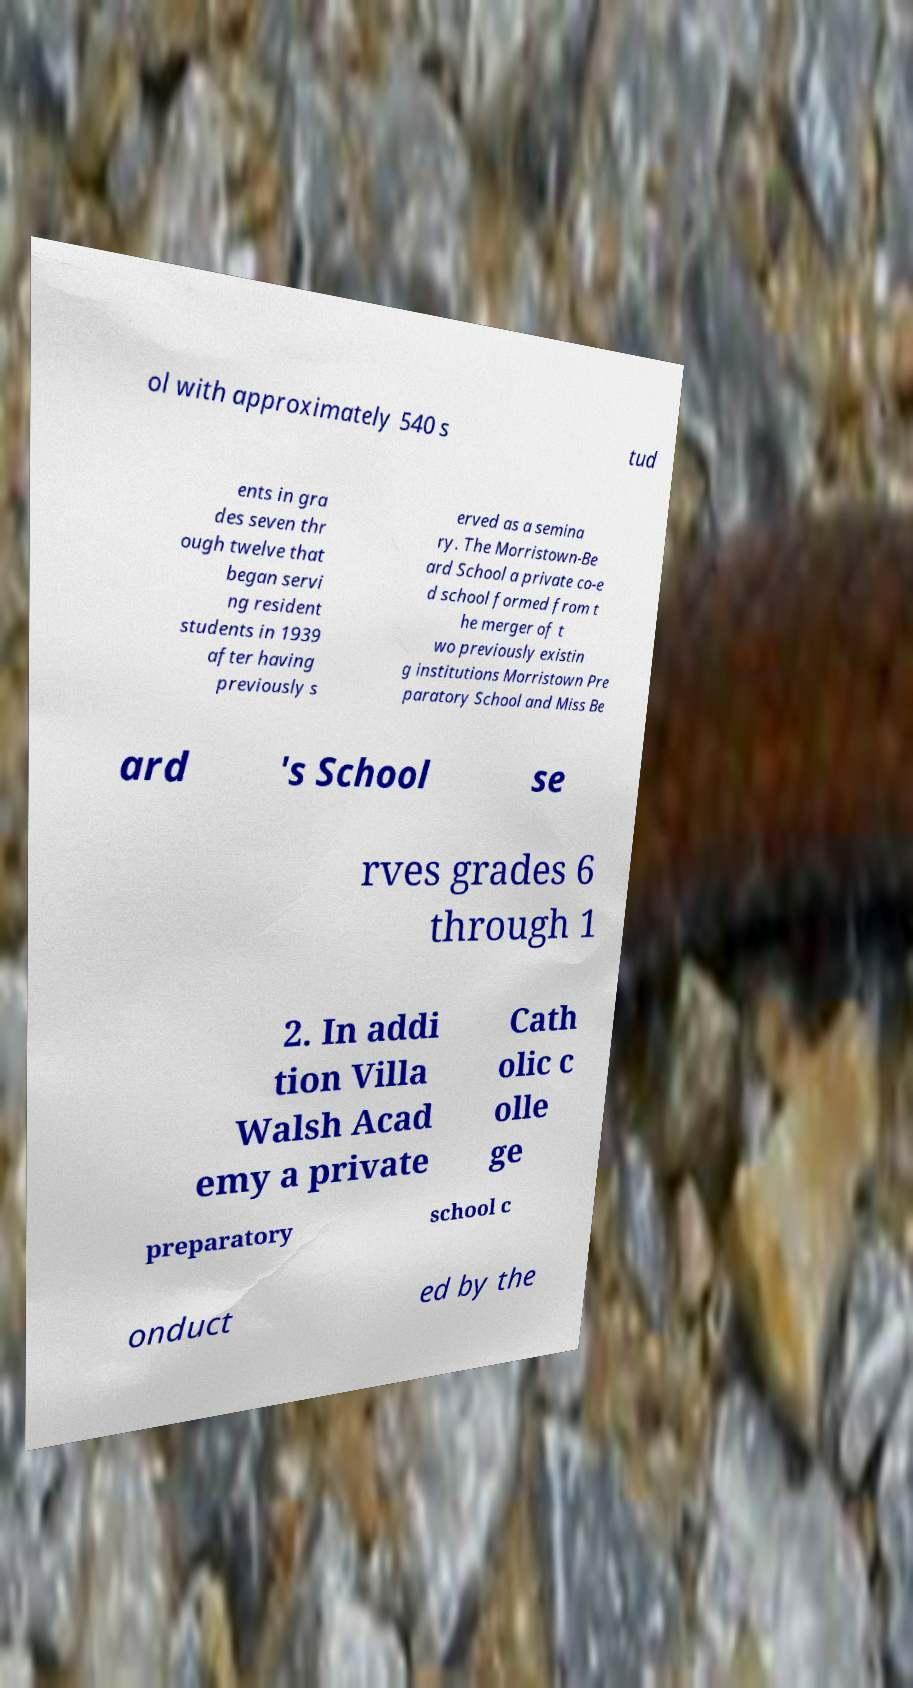I need the written content from this picture converted into text. Can you do that? ol with approximately 540 s tud ents in gra des seven thr ough twelve that began servi ng resident students in 1939 after having previously s erved as a semina ry. The Morristown-Be ard School a private co-e d school formed from t he merger of t wo previously existin g institutions Morristown Pre paratory School and Miss Be ard 's School se rves grades 6 through 1 2. In addi tion Villa Walsh Acad emy a private Cath olic c olle ge preparatory school c onduct ed by the 